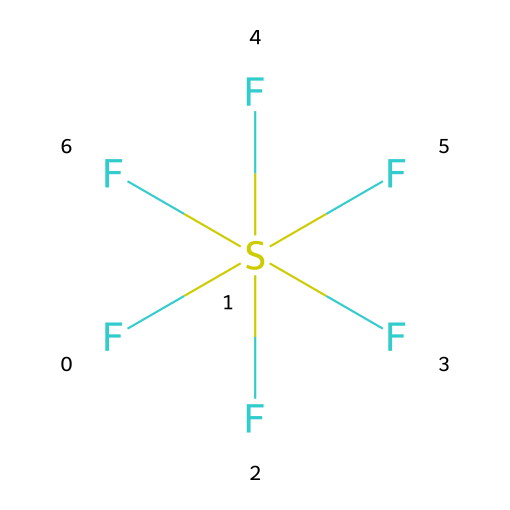What is the molecular formula of sulfur hexafluoride? The SMILES representation indicates that there is one sulfur atom (S) and six fluorine atoms (F), leading to the molecular formula SF6.
Answer: SF6 How many fluorine atoms are present in this molecule? By examining the SMILES, we see six 'F' characters, indicating the presence of six fluorine atoms.
Answer: 6 What type of bonding is present in sulfur hexafluoride? The structure indicates the presence of covalent bonds between the sulfur atom and each of the six fluorine atoms, as evidenced by the way they are represented in the SMILES.
Answer: covalent Is sulfur hexafluoride a hypervalent compound? The given chemical contains a sulfur atom that is bonded to more than four other atoms (six in total), which classifies it as a hypervalent compound.
Answer: yes Why is sulfur hexafluoride used in sound-altering demonstrations? Sulfur hexafluoride is denser than air, which allows it to alter the pitch of sound when inhaled or used in demonstrations, taking advantage of its unique physical properties rather than chemical reactivity.
Answer: density What is the central atom in sulfur hexafluoride? In the given molecule, sulfur (S) is the central atom that is surrounded by the six fluorine atoms, indicating its role as the focal point of the molecular structure.
Answer: sulfur How many total atoms are in sulfur hexafluoride? There is one sulfur atom and six fluorine atoms, so when counted together, there are a total of seven atoms in the molecular structure.
Answer: 7 